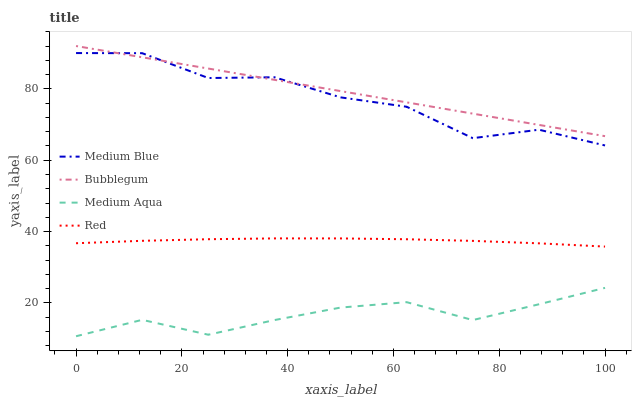Does Medium Aqua have the minimum area under the curve?
Answer yes or no. Yes. Does Bubblegum have the maximum area under the curve?
Answer yes or no. Yes. Does Medium Blue have the minimum area under the curve?
Answer yes or no. No. Does Medium Blue have the maximum area under the curve?
Answer yes or no. No. Is Bubblegum the smoothest?
Answer yes or no. Yes. Is Medium Blue the roughest?
Answer yes or no. Yes. Is Red the smoothest?
Answer yes or no. No. Is Red the roughest?
Answer yes or no. No. Does Medium Aqua have the lowest value?
Answer yes or no. Yes. Does Medium Blue have the lowest value?
Answer yes or no. No. Does Bubblegum have the highest value?
Answer yes or no. Yes. Does Medium Blue have the highest value?
Answer yes or no. No. Is Medium Aqua less than Bubblegum?
Answer yes or no. Yes. Is Bubblegum greater than Medium Aqua?
Answer yes or no. Yes. Does Medium Blue intersect Bubblegum?
Answer yes or no. Yes. Is Medium Blue less than Bubblegum?
Answer yes or no. No. Is Medium Blue greater than Bubblegum?
Answer yes or no. No. Does Medium Aqua intersect Bubblegum?
Answer yes or no. No. 